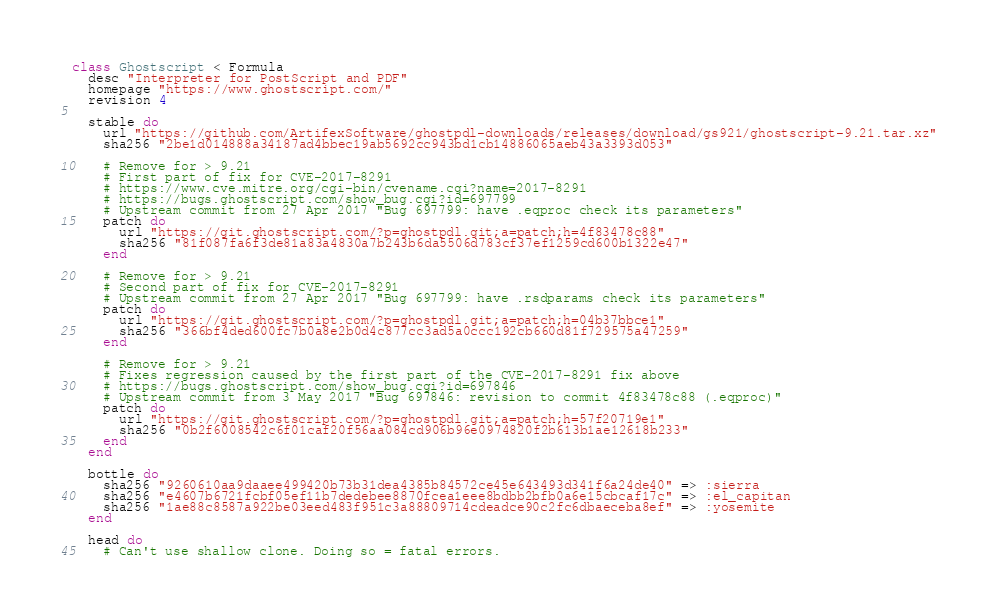<code> <loc_0><loc_0><loc_500><loc_500><_Ruby_>class Ghostscript < Formula
  desc "Interpreter for PostScript and PDF"
  homepage "https://www.ghostscript.com/"
  revision 4

  stable do
    url "https://github.com/ArtifexSoftware/ghostpdl-downloads/releases/download/gs921/ghostscript-9.21.tar.xz"
    sha256 "2be1d014888a34187ad4bbec19ab5692cc943bd1cb14886065aeb43a3393d053"

    # Remove for > 9.21
    # First part of fix for CVE-2017-8291
    # https://www.cve.mitre.org/cgi-bin/cvename.cgi?name=2017-8291
    # https://bugs.ghostscript.com/show_bug.cgi?id=697799
    # Upstream commit from 27 Apr 2017 "Bug 697799: have .eqproc check its parameters"
    patch do
      url "https://git.ghostscript.com/?p=ghostpdl.git;a=patch;h=4f83478c88"
      sha256 "81f087fa6f3de81a83a4830a7b243b6da5506d783cf37ef1259cd600b1322e47"
    end

    # Remove for > 9.21
    # Second part of fix for CVE-2017-8291
    # Upstream commit from 27 Apr 2017 "Bug 697799: have .rsdparams check its parameters"
    patch do
      url "https://git.ghostscript.com/?p=ghostpdl.git;a=patch;h=04b37bbce1"
      sha256 "366bf4ded600fc7b0a8e2b0d4c877cc3ad5a0ccc192cb660d81f729575a47259"
    end

    # Remove for > 9.21
    # Fixes regression caused by the first part of the CVE-2017-8291 fix above
    # https://bugs.ghostscript.com/show_bug.cgi?id=697846
    # Upstream commit from 3 May 2017 "Bug 697846: revision to commit 4f83478c88 (.eqproc)"
    patch do
      url "https://git.ghostscript.com/?p=ghostpdl.git;a=patch;h=57f20719e1"
      sha256 "0b2f6008542c6f01caf20f56aa084cd906b96e0974820f2b613b1ae12618b233"
    end
  end

  bottle do
    sha256 "9260610aa9daaee499420b73b31dea4385b84572ce45e643493d341f6a24de40" => :sierra
    sha256 "e4607b6721fcbf05ef11b7dedebee8870fcea1eee8bdbb2bfb0a6e15cbcaf17c" => :el_capitan
    sha256 "1ae88c8587a922be03eed483f951c3a88809714cdeadce90c2fc6dbaeceba8ef" => :yosemite
  end

  head do
    # Can't use shallow clone. Doing so = fatal errors.</code> 